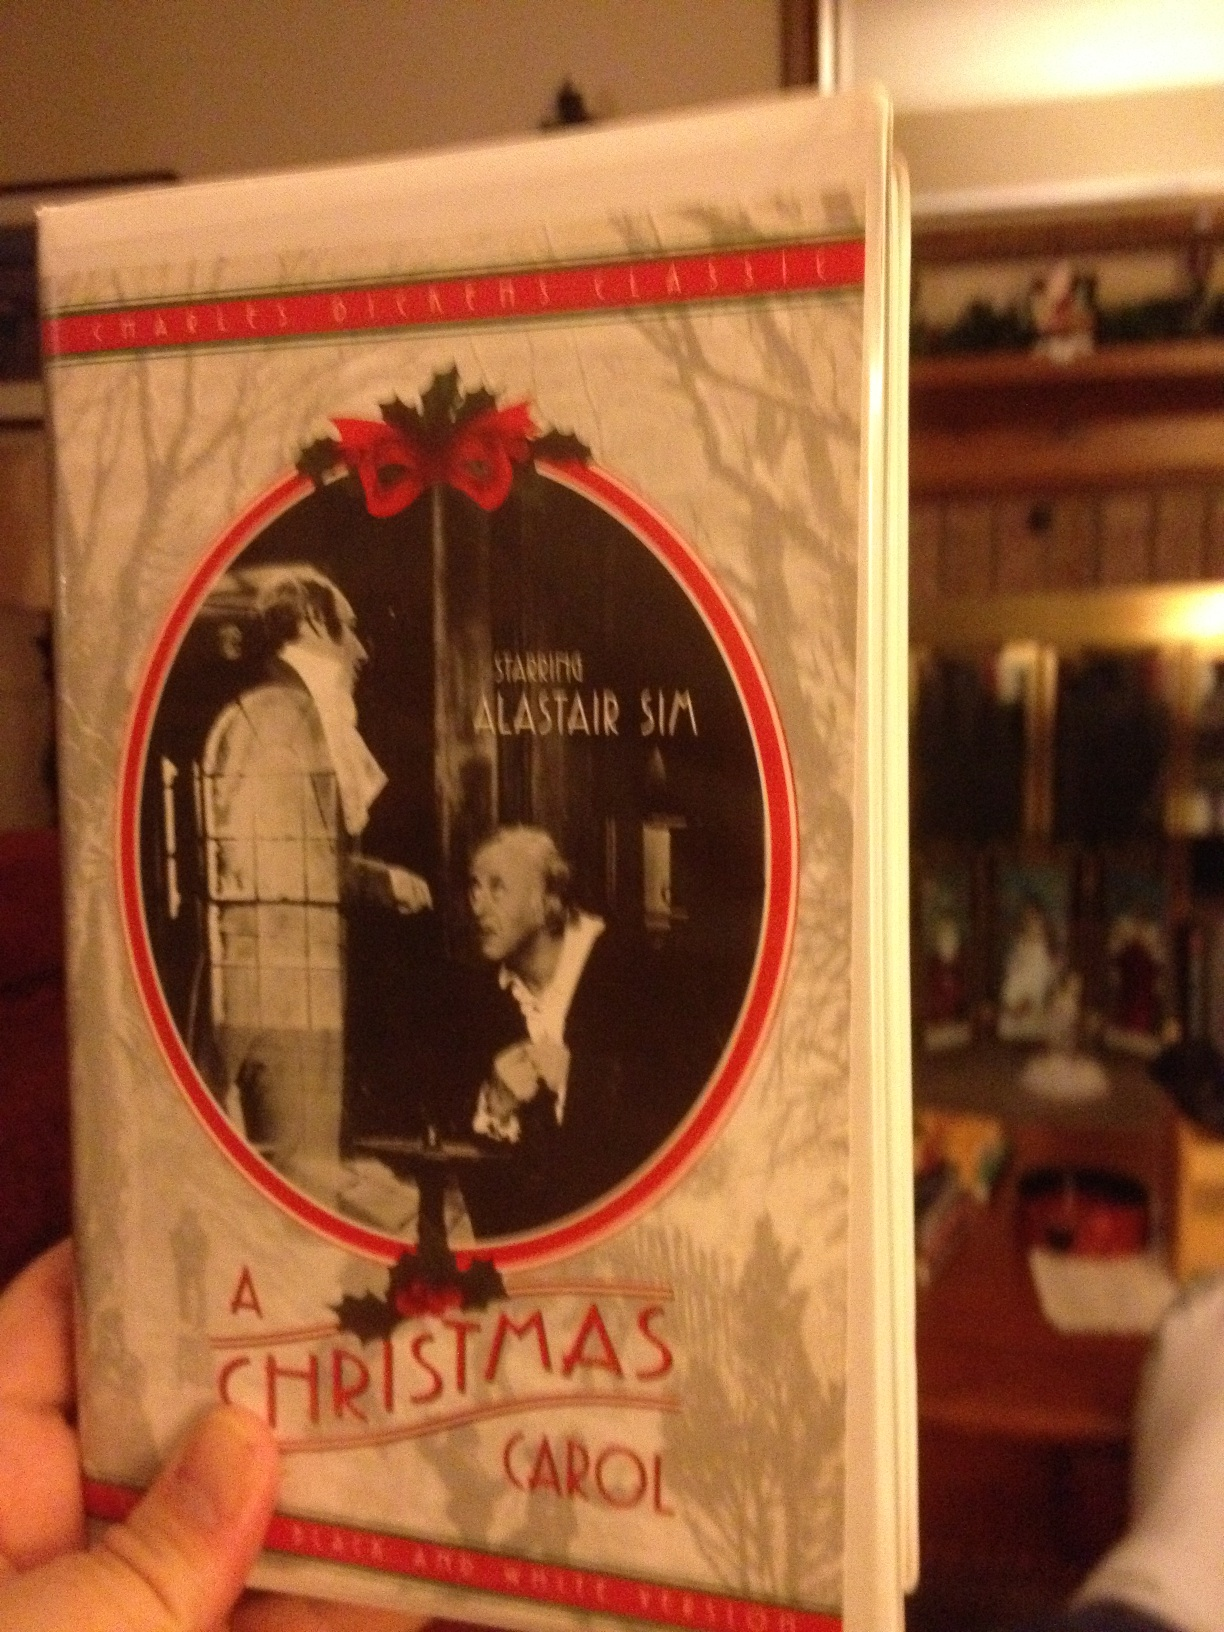Describe the plot of the story adapted in this film. The plot of 'A Christmas Carol' revolves around Ebenezer Scrooge, a wealthy but cold-hearted miser whose only concern is money. On Christmas Eve, Scrooge is visited by the ghost of his former business partner, Jacob Marley, who warns him of the consequences of his sinful ways. Scrooge is then visited by three spirits: the Ghost of Christmas Past, the Ghost of Christmas Present, and the Ghost of Christmas Yet to Come. These spirits show him scenes from his past, present, and future, culminating in a vision of Scrooge's lonely death. This haunting experience transforms Scrooge, leading him to embrace the spirit of Christmas, showing kindness and generosity to those around him. 